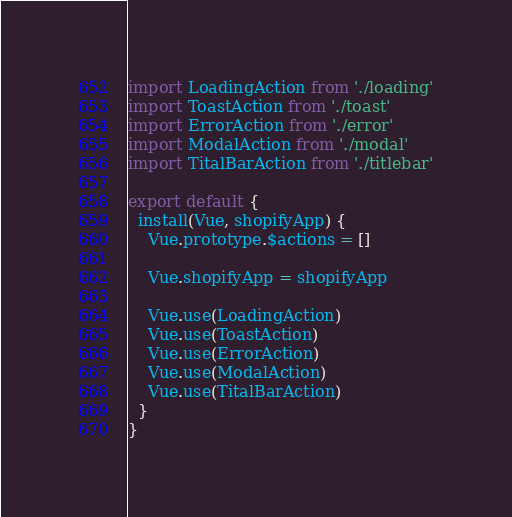<code> <loc_0><loc_0><loc_500><loc_500><_JavaScript_>import LoadingAction from './loading'
import ToastAction from './toast'
import ErrorAction from './error'
import ModalAction from './modal'
import TitalBarAction from './titlebar'

export default {
  install(Vue, shopifyApp) {
    Vue.prototype.$actions = []

    Vue.shopifyApp = shopifyApp

    Vue.use(LoadingAction)
    Vue.use(ToastAction)
    Vue.use(ErrorAction)
    Vue.use(ModalAction)
    Vue.use(TitalBarAction)
  }
}
</code> 